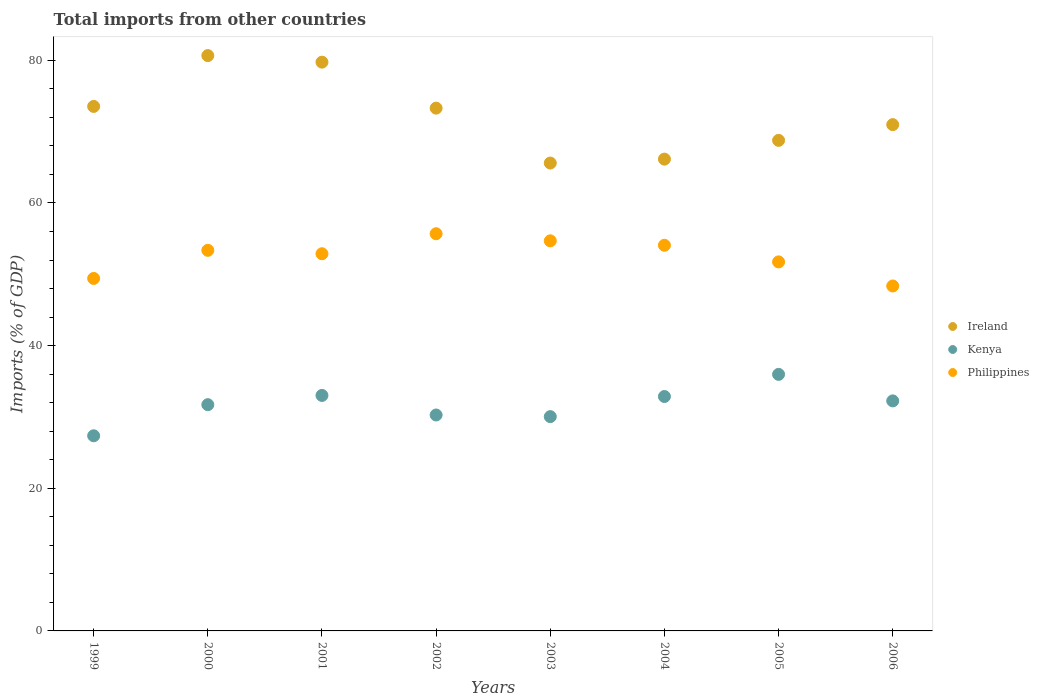How many different coloured dotlines are there?
Your answer should be very brief. 3. What is the total imports in Ireland in 2001?
Your response must be concise. 79.74. Across all years, what is the maximum total imports in Philippines?
Ensure brevity in your answer.  55.69. Across all years, what is the minimum total imports in Kenya?
Make the answer very short. 27.36. In which year was the total imports in Philippines minimum?
Your response must be concise. 2006. What is the total total imports in Kenya in the graph?
Give a very brief answer. 253.5. What is the difference between the total imports in Philippines in 2000 and that in 2001?
Give a very brief answer. 0.48. What is the difference between the total imports in Philippines in 2006 and the total imports in Kenya in 2001?
Offer a terse response. 15.35. What is the average total imports in Philippines per year?
Your response must be concise. 52.53. In the year 2001, what is the difference between the total imports in Ireland and total imports in Philippines?
Give a very brief answer. 26.86. What is the ratio of the total imports in Kenya in 2003 to that in 2004?
Your answer should be very brief. 0.91. What is the difference between the highest and the second highest total imports in Philippines?
Offer a very short reply. 1. What is the difference between the highest and the lowest total imports in Kenya?
Keep it short and to the point. 8.61. In how many years, is the total imports in Kenya greater than the average total imports in Kenya taken over all years?
Offer a terse response. 5. Is the sum of the total imports in Kenya in 2004 and 2005 greater than the maximum total imports in Philippines across all years?
Ensure brevity in your answer.  Yes. Does the total imports in Kenya monotonically increase over the years?
Make the answer very short. No. How many dotlines are there?
Your response must be concise. 3. How many years are there in the graph?
Provide a short and direct response. 8. Are the values on the major ticks of Y-axis written in scientific E-notation?
Your answer should be compact. No. Does the graph contain any zero values?
Your answer should be compact. No. Does the graph contain grids?
Your response must be concise. No. How many legend labels are there?
Keep it short and to the point. 3. What is the title of the graph?
Your answer should be compact. Total imports from other countries. What is the label or title of the Y-axis?
Your answer should be compact. Imports (% of GDP). What is the Imports (% of GDP) of Ireland in 1999?
Your answer should be compact. 73.54. What is the Imports (% of GDP) of Kenya in 1999?
Keep it short and to the point. 27.36. What is the Imports (% of GDP) in Philippines in 1999?
Keep it short and to the point. 49.42. What is the Imports (% of GDP) in Ireland in 2000?
Give a very brief answer. 80.67. What is the Imports (% of GDP) in Kenya in 2000?
Give a very brief answer. 31.72. What is the Imports (% of GDP) in Philippines in 2000?
Ensure brevity in your answer.  53.36. What is the Imports (% of GDP) of Ireland in 2001?
Your answer should be compact. 79.74. What is the Imports (% of GDP) of Kenya in 2001?
Provide a short and direct response. 33.02. What is the Imports (% of GDP) of Philippines in 2001?
Your response must be concise. 52.88. What is the Imports (% of GDP) in Ireland in 2002?
Your answer should be compact. 73.3. What is the Imports (% of GDP) of Kenya in 2002?
Provide a succinct answer. 30.27. What is the Imports (% of GDP) of Philippines in 2002?
Your answer should be very brief. 55.69. What is the Imports (% of GDP) of Ireland in 2003?
Your response must be concise. 65.6. What is the Imports (% of GDP) in Kenya in 2003?
Provide a short and direct response. 30.05. What is the Imports (% of GDP) in Philippines in 2003?
Keep it short and to the point. 54.69. What is the Imports (% of GDP) in Ireland in 2004?
Keep it short and to the point. 66.15. What is the Imports (% of GDP) in Kenya in 2004?
Make the answer very short. 32.87. What is the Imports (% of GDP) in Philippines in 2004?
Offer a terse response. 54.07. What is the Imports (% of GDP) of Ireland in 2005?
Keep it short and to the point. 68.78. What is the Imports (% of GDP) of Kenya in 2005?
Offer a terse response. 35.97. What is the Imports (% of GDP) in Philippines in 2005?
Your answer should be very brief. 51.74. What is the Imports (% of GDP) in Ireland in 2006?
Your answer should be compact. 70.98. What is the Imports (% of GDP) in Kenya in 2006?
Provide a succinct answer. 32.25. What is the Imports (% of GDP) of Philippines in 2006?
Your answer should be very brief. 48.36. Across all years, what is the maximum Imports (% of GDP) in Ireland?
Your response must be concise. 80.67. Across all years, what is the maximum Imports (% of GDP) of Kenya?
Your answer should be compact. 35.97. Across all years, what is the maximum Imports (% of GDP) in Philippines?
Your answer should be very brief. 55.69. Across all years, what is the minimum Imports (% of GDP) of Ireland?
Your answer should be very brief. 65.6. Across all years, what is the minimum Imports (% of GDP) in Kenya?
Offer a terse response. 27.36. Across all years, what is the minimum Imports (% of GDP) of Philippines?
Provide a short and direct response. 48.36. What is the total Imports (% of GDP) of Ireland in the graph?
Ensure brevity in your answer.  578.76. What is the total Imports (% of GDP) in Kenya in the graph?
Offer a terse response. 253.5. What is the total Imports (% of GDP) of Philippines in the graph?
Provide a succinct answer. 420.22. What is the difference between the Imports (% of GDP) in Ireland in 1999 and that in 2000?
Offer a terse response. -7.13. What is the difference between the Imports (% of GDP) in Kenya in 1999 and that in 2000?
Your answer should be very brief. -4.36. What is the difference between the Imports (% of GDP) in Philippines in 1999 and that in 2000?
Provide a short and direct response. -3.94. What is the difference between the Imports (% of GDP) of Ireland in 1999 and that in 2001?
Give a very brief answer. -6.21. What is the difference between the Imports (% of GDP) of Kenya in 1999 and that in 2001?
Offer a terse response. -5.66. What is the difference between the Imports (% of GDP) of Philippines in 1999 and that in 2001?
Offer a terse response. -3.46. What is the difference between the Imports (% of GDP) of Ireland in 1999 and that in 2002?
Keep it short and to the point. 0.24. What is the difference between the Imports (% of GDP) in Kenya in 1999 and that in 2002?
Ensure brevity in your answer.  -2.92. What is the difference between the Imports (% of GDP) in Philippines in 1999 and that in 2002?
Your answer should be very brief. -6.27. What is the difference between the Imports (% of GDP) of Ireland in 1999 and that in 2003?
Your answer should be compact. 7.94. What is the difference between the Imports (% of GDP) in Kenya in 1999 and that in 2003?
Your response must be concise. -2.69. What is the difference between the Imports (% of GDP) in Philippines in 1999 and that in 2003?
Offer a very short reply. -5.27. What is the difference between the Imports (% of GDP) in Ireland in 1999 and that in 2004?
Make the answer very short. 7.39. What is the difference between the Imports (% of GDP) in Kenya in 1999 and that in 2004?
Ensure brevity in your answer.  -5.51. What is the difference between the Imports (% of GDP) of Philippines in 1999 and that in 2004?
Offer a terse response. -4.65. What is the difference between the Imports (% of GDP) of Ireland in 1999 and that in 2005?
Make the answer very short. 4.76. What is the difference between the Imports (% of GDP) of Kenya in 1999 and that in 2005?
Ensure brevity in your answer.  -8.61. What is the difference between the Imports (% of GDP) of Philippines in 1999 and that in 2005?
Offer a very short reply. -2.32. What is the difference between the Imports (% of GDP) of Ireland in 1999 and that in 2006?
Keep it short and to the point. 2.56. What is the difference between the Imports (% of GDP) in Kenya in 1999 and that in 2006?
Keep it short and to the point. -4.89. What is the difference between the Imports (% of GDP) of Philippines in 1999 and that in 2006?
Keep it short and to the point. 1.06. What is the difference between the Imports (% of GDP) in Ireland in 2000 and that in 2001?
Offer a very short reply. 0.92. What is the difference between the Imports (% of GDP) of Kenya in 2000 and that in 2001?
Offer a very short reply. -1.29. What is the difference between the Imports (% of GDP) of Philippines in 2000 and that in 2001?
Make the answer very short. 0.48. What is the difference between the Imports (% of GDP) of Ireland in 2000 and that in 2002?
Give a very brief answer. 7.37. What is the difference between the Imports (% of GDP) in Kenya in 2000 and that in 2002?
Provide a succinct answer. 1.45. What is the difference between the Imports (% of GDP) of Philippines in 2000 and that in 2002?
Make the answer very short. -2.33. What is the difference between the Imports (% of GDP) of Ireland in 2000 and that in 2003?
Keep it short and to the point. 15.07. What is the difference between the Imports (% of GDP) of Kenya in 2000 and that in 2003?
Ensure brevity in your answer.  1.68. What is the difference between the Imports (% of GDP) in Philippines in 2000 and that in 2003?
Your response must be concise. -1.33. What is the difference between the Imports (% of GDP) of Ireland in 2000 and that in 2004?
Make the answer very short. 14.52. What is the difference between the Imports (% of GDP) of Kenya in 2000 and that in 2004?
Your answer should be very brief. -1.15. What is the difference between the Imports (% of GDP) of Philippines in 2000 and that in 2004?
Your answer should be compact. -0.71. What is the difference between the Imports (% of GDP) in Ireland in 2000 and that in 2005?
Offer a very short reply. 11.89. What is the difference between the Imports (% of GDP) of Kenya in 2000 and that in 2005?
Provide a short and direct response. -4.25. What is the difference between the Imports (% of GDP) of Philippines in 2000 and that in 2005?
Your answer should be compact. 1.62. What is the difference between the Imports (% of GDP) of Ireland in 2000 and that in 2006?
Keep it short and to the point. 9.68. What is the difference between the Imports (% of GDP) in Kenya in 2000 and that in 2006?
Give a very brief answer. -0.53. What is the difference between the Imports (% of GDP) in Philippines in 2000 and that in 2006?
Provide a short and direct response. 5. What is the difference between the Imports (% of GDP) in Ireland in 2001 and that in 2002?
Your answer should be very brief. 6.45. What is the difference between the Imports (% of GDP) in Kenya in 2001 and that in 2002?
Ensure brevity in your answer.  2.74. What is the difference between the Imports (% of GDP) in Philippines in 2001 and that in 2002?
Keep it short and to the point. -2.81. What is the difference between the Imports (% of GDP) in Ireland in 2001 and that in 2003?
Offer a terse response. 14.15. What is the difference between the Imports (% of GDP) of Kenya in 2001 and that in 2003?
Offer a very short reply. 2.97. What is the difference between the Imports (% of GDP) in Philippines in 2001 and that in 2003?
Ensure brevity in your answer.  -1.81. What is the difference between the Imports (% of GDP) in Ireland in 2001 and that in 2004?
Provide a succinct answer. 13.6. What is the difference between the Imports (% of GDP) of Kenya in 2001 and that in 2004?
Give a very brief answer. 0.15. What is the difference between the Imports (% of GDP) of Philippines in 2001 and that in 2004?
Your response must be concise. -1.19. What is the difference between the Imports (% of GDP) in Ireland in 2001 and that in 2005?
Make the answer very short. 10.96. What is the difference between the Imports (% of GDP) of Kenya in 2001 and that in 2005?
Provide a succinct answer. -2.95. What is the difference between the Imports (% of GDP) in Philippines in 2001 and that in 2005?
Offer a terse response. 1.14. What is the difference between the Imports (% of GDP) in Ireland in 2001 and that in 2006?
Provide a succinct answer. 8.76. What is the difference between the Imports (% of GDP) of Kenya in 2001 and that in 2006?
Provide a succinct answer. 0.76. What is the difference between the Imports (% of GDP) in Philippines in 2001 and that in 2006?
Give a very brief answer. 4.52. What is the difference between the Imports (% of GDP) of Ireland in 2002 and that in 2003?
Offer a terse response. 7.7. What is the difference between the Imports (% of GDP) in Kenya in 2002 and that in 2003?
Your answer should be very brief. 0.23. What is the difference between the Imports (% of GDP) of Philippines in 2002 and that in 2003?
Offer a very short reply. 1. What is the difference between the Imports (% of GDP) in Ireland in 2002 and that in 2004?
Give a very brief answer. 7.15. What is the difference between the Imports (% of GDP) in Kenya in 2002 and that in 2004?
Offer a very short reply. -2.59. What is the difference between the Imports (% of GDP) in Philippines in 2002 and that in 2004?
Your answer should be compact. 1.62. What is the difference between the Imports (% of GDP) in Ireland in 2002 and that in 2005?
Your answer should be very brief. 4.52. What is the difference between the Imports (% of GDP) of Kenya in 2002 and that in 2005?
Give a very brief answer. -5.7. What is the difference between the Imports (% of GDP) of Philippines in 2002 and that in 2005?
Ensure brevity in your answer.  3.95. What is the difference between the Imports (% of GDP) in Ireland in 2002 and that in 2006?
Give a very brief answer. 2.31. What is the difference between the Imports (% of GDP) of Kenya in 2002 and that in 2006?
Offer a terse response. -1.98. What is the difference between the Imports (% of GDP) of Philippines in 2002 and that in 2006?
Provide a short and direct response. 7.33. What is the difference between the Imports (% of GDP) in Ireland in 2003 and that in 2004?
Make the answer very short. -0.55. What is the difference between the Imports (% of GDP) in Kenya in 2003 and that in 2004?
Provide a short and direct response. -2.82. What is the difference between the Imports (% of GDP) of Philippines in 2003 and that in 2004?
Ensure brevity in your answer.  0.62. What is the difference between the Imports (% of GDP) in Ireland in 2003 and that in 2005?
Ensure brevity in your answer.  -3.18. What is the difference between the Imports (% of GDP) of Kenya in 2003 and that in 2005?
Offer a terse response. -5.92. What is the difference between the Imports (% of GDP) of Philippines in 2003 and that in 2005?
Ensure brevity in your answer.  2.95. What is the difference between the Imports (% of GDP) of Ireland in 2003 and that in 2006?
Provide a succinct answer. -5.38. What is the difference between the Imports (% of GDP) in Kenya in 2003 and that in 2006?
Ensure brevity in your answer.  -2.21. What is the difference between the Imports (% of GDP) in Philippines in 2003 and that in 2006?
Offer a terse response. 6.33. What is the difference between the Imports (% of GDP) of Ireland in 2004 and that in 2005?
Provide a short and direct response. -2.63. What is the difference between the Imports (% of GDP) in Kenya in 2004 and that in 2005?
Your response must be concise. -3.1. What is the difference between the Imports (% of GDP) of Philippines in 2004 and that in 2005?
Provide a short and direct response. 2.33. What is the difference between the Imports (% of GDP) in Ireland in 2004 and that in 2006?
Your answer should be very brief. -4.84. What is the difference between the Imports (% of GDP) in Kenya in 2004 and that in 2006?
Your answer should be compact. 0.62. What is the difference between the Imports (% of GDP) of Philippines in 2004 and that in 2006?
Provide a short and direct response. 5.71. What is the difference between the Imports (% of GDP) in Ireland in 2005 and that in 2006?
Your answer should be compact. -2.2. What is the difference between the Imports (% of GDP) of Kenya in 2005 and that in 2006?
Keep it short and to the point. 3.72. What is the difference between the Imports (% of GDP) in Philippines in 2005 and that in 2006?
Provide a succinct answer. 3.38. What is the difference between the Imports (% of GDP) of Ireland in 1999 and the Imports (% of GDP) of Kenya in 2000?
Offer a terse response. 41.82. What is the difference between the Imports (% of GDP) in Ireland in 1999 and the Imports (% of GDP) in Philippines in 2000?
Provide a succinct answer. 20.18. What is the difference between the Imports (% of GDP) in Kenya in 1999 and the Imports (% of GDP) in Philippines in 2000?
Give a very brief answer. -26. What is the difference between the Imports (% of GDP) in Ireland in 1999 and the Imports (% of GDP) in Kenya in 2001?
Provide a succinct answer. 40.52. What is the difference between the Imports (% of GDP) in Ireland in 1999 and the Imports (% of GDP) in Philippines in 2001?
Give a very brief answer. 20.66. What is the difference between the Imports (% of GDP) of Kenya in 1999 and the Imports (% of GDP) of Philippines in 2001?
Provide a short and direct response. -25.52. What is the difference between the Imports (% of GDP) in Ireland in 1999 and the Imports (% of GDP) in Kenya in 2002?
Your answer should be compact. 43.26. What is the difference between the Imports (% of GDP) in Ireland in 1999 and the Imports (% of GDP) in Philippines in 2002?
Keep it short and to the point. 17.85. What is the difference between the Imports (% of GDP) in Kenya in 1999 and the Imports (% of GDP) in Philippines in 2002?
Your response must be concise. -28.33. What is the difference between the Imports (% of GDP) of Ireland in 1999 and the Imports (% of GDP) of Kenya in 2003?
Your response must be concise. 43.49. What is the difference between the Imports (% of GDP) of Ireland in 1999 and the Imports (% of GDP) of Philippines in 2003?
Keep it short and to the point. 18.85. What is the difference between the Imports (% of GDP) of Kenya in 1999 and the Imports (% of GDP) of Philippines in 2003?
Ensure brevity in your answer.  -27.33. What is the difference between the Imports (% of GDP) in Ireland in 1999 and the Imports (% of GDP) in Kenya in 2004?
Give a very brief answer. 40.67. What is the difference between the Imports (% of GDP) in Ireland in 1999 and the Imports (% of GDP) in Philippines in 2004?
Provide a short and direct response. 19.47. What is the difference between the Imports (% of GDP) of Kenya in 1999 and the Imports (% of GDP) of Philippines in 2004?
Keep it short and to the point. -26.71. What is the difference between the Imports (% of GDP) of Ireland in 1999 and the Imports (% of GDP) of Kenya in 2005?
Give a very brief answer. 37.57. What is the difference between the Imports (% of GDP) of Ireland in 1999 and the Imports (% of GDP) of Philippines in 2005?
Give a very brief answer. 21.8. What is the difference between the Imports (% of GDP) of Kenya in 1999 and the Imports (% of GDP) of Philippines in 2005?
Keep it short and to the point. -24.38. What is the difference between the Imports (% of GDP) in Ireland in 1999 and the Imports (% of GDP) in Kenya in 2006?
Offer a very short reply. 41.29. What is the difference between the Imports (% of GDP) in Ireland in 1999 and the Imports (% of GDP) in Philippines in 2006?
Your answer should be compact. 25.18. What is the difference between the Imports (% of GDP) of Kenya in 1999 and the Imports (% of GDP) of Philippines in 2006?
Keep it short and to the point. -21. What is the difference between the Imports (% of GDP) of Ireland in 2000 and the Imports (% of GDP) of Kenya in 2001?
Your answer should be very brief. 47.65. What is the difference between the Imports (% of GDP) in Ireland in 2000 and the Imports (% of GDP) in Philippines in 2001?
Offer a very short reply. 27.78. What is the difference between the Imports (% of GDP) of Kenya in 2000 and the Imports (% of GDP) of Philippines in 2001?
Your response must be concise. -21.16. What is the difference between the Imports (% of GDP) in Ireland in 2000 and the Imports (% of GDP) in Kenya in 2002?
Ensure brevity in your answer.  50.39. What is the difference between the Imports (% of GDP) in Ireland in 2000 and the Imports (% of GDP) in Philippines in 2002?
Provide a short and direct response. 24.98. What is the difference between the Imports (% of GDP) of Kenya in 2000 and the Imports (% of GDP) of Philippines in 2002?
Keep it short and to the point. -23.97. What is the difference between the Imports (% of GDP) in Ireland in 2000 and the Imports (% of GDP) in Kenya in 2003?
Your response must be concise. 50.62. What is the difference between the Imports (% of GDP) in Ireland in 2000 and the Imports (% of GDP) in Philippines in 2003?
Your answer should be compact. 25.97. What is the difference between the Imports (% of GDP) of Kenya in 2000 and the Imports (% of GDP) of Philippines in 2003?
Provide a succinct answer. -22.97. What is the difference between the Imports (% of GDP) in Ireland in 2000 and the Imports (% of GDP) in Kenya in 2004?
Your answer should be compact. 47.8. What is the difference between the Imports (% of GDP) of Ireland in 2000 and the Imports (% of GDP) of Philippines in 2004?
Ensure brevity in your answer.  26.6. What is the difference between the Imports (% of GDP) in Kenya in 2000 and the Imports (% of GDP) in Philippines in 2004?
Your answer should be very brief. -22.35. What is the difference between the Imports (% of GDP) of Ireland in 2000 and the Imports (% of GDP) of Kenya in 2005?
Offer a very short reply. 44.7. What is the difference between the Imports (% of GDP) in Ireland in 2000 and the Imports (% of GDP) in Philippines in 2005?
Your answer should be compact. 28.92. What is the difference between the Imports (% of GDP) of Kenya in 2000 and the Imports (% of GDP) of Philippines in 2005?
Provide a short and direct response. -20.02. What is the difference between the Imports (% of GDP) of Ireland in 2000 and the Imports (% of GDP) of Kenya in 2006?
Your answer should be compact. 48.41. What is the difference between the Imports (% of GDP) in Ireland in 2000 and the Imports (% of GDP) in Philippines in 2006?
Keep it short and to the point. 32.3. What is the difference between the Imports (% of GDP) in Kenya in 2000 and the Imports (% of GDP) in Philippines in 2006?
Offer a terse response. -16.64. What is the difference between the Imports (% of GDP) of Ireland in 2001 and the Imports (% of GDP) of Kenya in 2002?
Keep it short and to the point. 49.47. What is the difference between the Imports (% of GDP) of Ireland in 2001 and the Imports (% of GDP) of Philippines in 2002?
Your answer should be very brief. 24.06. What is the difference between the Imports (% of GDP) in Kenya in 2001 and the Imports (% of GDP) in Philippines in 2002?
Provide a short and direct response. -22.67. What is the difference between the Imports (% of GDP) of Ireland in 2001 and the Imports (% of GDP) of Kenya in 2003?
Ensure brevity in your answer.  49.7. What is the difference between the Imports (% of GDP) in Ireland in 2001 and the Imports (% of GDP) in Philippines in 2003?
Offer a very short reply. 25.05. What is the difference between the Imports (% of GDP) of Kenya in 2001 and the Imports (% of GDP) of Philippines in 2003?
Your response must be concise. -21.68. What is the difference between the Imports (% of GDP) of Ireland in 2001 and the Imports (% of GDP) of Kenya in 2004?
Provide a short and direct response. 46.88. What is the difference between the Imports (% of GDP) of Ireland in 2001 and the Imports (% of GDP) of Philippines in 2004?
Offer a terse response. 25.67. What is the difference between the Imports (% of GDP) in Kenya in 2001 and the Imports (% of GDP) in Philippines in 2004?
Offer a terse response. -21.05. What is the difference between the Imports (% of GDP) of Ireland in 2001 and the Imports (% of GDP) of Kenya in 2005?
Your response must be concise. 43.77. What is the difference between the Imports (% of GDP) in Ireland in 2001 and the Imports (% of GDP) in Philippines in 2005?
Offer a terse response. 28. What is the difference between the Imports (% of GDP) of Kenya in 2001 and the Imports (% of GDP) of Philippines in 2005?
Offer a terse response. -18.73. What is the difference between the Imports (% of GDP) in Ireland in 2001 and the Imports (% of GDP) in Kenya in 2006?
Give a very brief answer. 47.49. What is the difference between the Imports (% of GDP) of Ireland in 2001 and the Imports (% of GDP) of Philippines in 2006?
Ensure brevity in your answer.  31.38. What is the difference between the Imports (% of GDP) of Kenya in 2001 and the Imports (% of GDP) of Philippines in 2006?
Your response must be concise. -15.35. What is the difference between the Imports (% of GDP) of Ireland in 2002 and the Imports (% of GDP) of Kenya in 2003?
Keep it short and to the point. 43.25. What is the difference between the Imports (% of GDP) of Ireland in 2002 and the Imports (% of GDP) of Philippines in 2003?
Your answer should be very brief. 18.61. What is the difference between the Imports (% of GDP) in Kenya in 2002 and the Imports (% of GDP) in Philippines in 2003?
Offer a very short reply. -24.42. What is the difference between the Imports (% of GDP) of Ireland in 2002 and the Imports (% of GDP) of Kenya in 2004?
Give a very brief answer. 40.43. What is the difference between the Imports (% of GDP) of Ireland in 2002 and the Imports (% of GDP) of Philippines in 2004?
Keep it short and to the point. 19.23. What is the difference between the Imports (% of GDP) in Kenya in 2002 and the Imports (% of GDP) in Philippines in 2004?
Keep it short and to the point. -23.8. What is the difference between the Imports (% of GDP) of Ireland in 2002 and the Imports (% of GDP) of Kenya in 2005?
Ensure brevity in your answer.  37.33. What is the difference between the Imports (% of GDP) in Ireland in 2002 and the Imports (% of GDP) in Philippines in 2005?
Offer a terse response. 21.56. What is the difference between the Imports (% of GDP) of Kenya in 2002 and the Imports (% of GDP) of Philippines in 2005?
Your answer should be compact. -21.47. What is the difference between the Imports (% of GDP) of Ireland in 2002 and the Imports (% of GDP) of Kenya in 2006?
Your answer should be very brief. 41.05. What is the difference between the Imports (% of GDP) of Ireland in 2002 and the Imports (% of GDP) of Philippines in 2006?
Offer a terse response. 24.93. What is the difference between the Imports (% of GDP) in Kenya in 2002 and the Imports (% of GDP) in Philippines in 2006?
Your answer should be very brief. -18.09. What is the difference between the Imports (% of GDP) in Ireland in 2003 and the Imports (% of GDP) in Kenya in 2004?
Provide a short and direct response. 32.73. What is the difference between the Imports (% of GDP) in Ireland in 2003 and the Imports (% of GDP) in Philippines in 2004?
Your response must be concise. 11.53. What is the difference between the Imports (% of GDP) in Kenya in 2003 and the Imports (% of GDP) in Philippines in 2004?
Ensure brevity in your answer.  -24.02. What is the difference between the Imports (% of GDP) of Ireland in 2003 and the Imports (% of GDP) of Kenya in 2005?
Ensure brevity in your answer.  29.63. What is the difference between the Imports (% of GDP) of Ireland in 2003 and the Imports (% of GDP) of Philippines in 2005?
Keep it short and to the point. 13.86. What is the difference between the Imports (% of GDP) of Kenya in 2003 and the Imports (% of GDP) of Philippines in 2005?
Provide a short and direct response. -21.7. What is the difference between the Imports (% of GDP) of Ireland in 2003 and the Imports (% of GDP) of Kenya in 2006?
Your answer should be compact. 33.35. What is the difference between the Imports (% of GDP) in Ireland in 2003 and the Imports (% of GDP) in Philippines in 2006?
Provide a short and direct response. 17.24. What is the difference between the Imports (% of GDP) in Kenya in 2003 and the Imports (% of GDP) in Philippines in 2006?
Give a very brief answer. -18.32. What is the difference between the Imports (% of GDP) in Ireland in 2004 and the Imports (% of GDP) in Kenya in 2005?
Provide a short and direct response. 30.18. What is the difference between the Imports (% of GDP) of Ireland in 2004 and the Imports (% of GDP) of Philippines in 2005?
Ensure brevity in your answer.  14.41. What is the difference between the Imports (% of GDP) in Kenya in 2004 and the Imports (% of GDP) in Philippines in 2005?
Provide a succinct answer. -18.87. What is the difference between the Imports (% of GDP) of Ireland in 2004 and the Imports (% of GDP) of Kenya in 2006?
Your answer should be compact. 33.9. What is the difference between the Imports (% of GDP) in Ireland in 2004 and the Imports (% of GDP) in Philippines in 2006?
Give a very brief answer. 17.78. What is the difference between the Imports (% of GDP) of Kenya in 2004 and the Imports (% of GDP) of Philippines in 2006?
Ensure brevity in your answer.  -15.5. What is the difference between the Imports (% of GDP) of Ireland in 2005 and the Imports (% of GDP) of Kenya in 2006?
Provide a short and direct response. 36.53. What is the difference between the Imports (% of GDP) in Ireland in 2005 and the Imports (% of GDP) in Philippines in 2006?
Offer a very short reply. 20.42. What is the difference between the Imports (% of GDP) in Kenya in 2005 and the Imports (% of GDP) in Philippines in 2006?
Offer a terse response. -12.39. What is the average Imports (% of GDP) of Ireland per year?
Offer a terse response. 72.34. What is the average Imports (% of GDP) of Kenya per year?
Your response must be concise. 31.69. What is the average Imports (% of GDP) in Philippines per year?
Your response must be concise. 52.53. In the year 1999, what is the difference between the Imports (% of GDP) of Ireland and Imports (% of GDP) of Kenya?
Provide a succinct answer. 46.18. In the year 1999, what is the difference between the Imports (% of GDP) of Ireland and Imports (% of GDP) of Philippines?
Keep it short and to the point. 24.12. In the year 1999, what is the difference between the Imports (% of GDP) in Kenya and Imports (% of GDP) in Philippines?
Your answer should be very brief. -22.06. In the year 2000, what is the difference between the Imports (% of GDP) of Ireland and Imports (% of GDP) of Kenya?
Your answer should be very brief. 48.94. In the year 2000, what is the difference between the Imports (% of GDP) of Ireland and Imports (% of GDP) of Philippines?
Provide a short and direct response. 27.31. In the year 2000, what is the difference between the Imports (% of GDP) in Kenya and Imports (% of GDP) in Philippines?
Ensure brevity in your answer.  -21.64. In the year 2001, what is the difference between the Imports (% of GDP) in Ireland and Imports (% of GDP) in Kenya?
Provide a succinct answer. 46.73. In the year 2001, what is the difference between the Imports (% of GDP) of Ireland and Imports (% of GDP) of Philippines?
Make the answer very short. 26.86. In the year 2001, what is the difference between the Imports (% of GDP) of Kenya and Imports (% of GDP) of Philippines?
Your answer should be very brief. -19.87. In the year 2002, what is the difference between the Imports (% of GDP) in Ireland and Imports (% of GDP) in Kenya?
Provide a short and direct response. 43.02. In the year 2002, what is the difference between the Imports (% of GDP) of Ireland and Imports (% of GDP) of Philippines?
Your answer should be very brief. 17.61. In the year 2002, what is the difference between the Imports (% of GDP) of Kenya and Imports (% of GDP) of Philippines?
Your response must be concise. -25.41. In the year 2003, what is the difference between the Imports (% of GDP) of Ireland and Imports (% of GDP) of Kenya?
Ensure brevity in your answer.  35.55. In the year 2003, what is the difference between the Imports (% of GDP) in Ireland and Imports (% of GDP) in Philippines?
Offer a very short reply. 10.91. In the year 2003, what is the difference between the Imports (% of GDP) in Kenya and Imports (% of GDP) in Philippines?
Your response must be concise. -24.65. In the year 2004, what is the difference between the Imports (% of GDP) in Ireland and Imports (% of GDP) in Kenya?
Provide a short and direct response. 33.28. In the year 2004, what is the difference between the Imports (% of GDP) of Ireland and Imports (% of GDP) of Philippines?
Your response must be concise. 12.08. In the year 2004, what is the difference between the Imports (% of GDP) of Kenya and Imports (% of GDP) of Philippines?
Provide a succinct answer. -21.2. In the year 2005, what is the difference between the Imports (% of GDP) of Ireland and Imports (% of GDP) of Kenya?
Provide a succinct answer. 32.81. In the year 2005, what is the difference between the Imports (% of GDP) of Ireland and Imports (% of GDP) of Philippines?
Give a very brief answer. 17.04. In the year 2005, what is the difference between the Imports (% of GDP) of Kenya and Imports (% of GDP) of Philippines?
Offer a very short reply. -15.77. In the year 2006, what is the difference between the Imports (% of GDP) in Ireland and Imports (% of GDP) in Kenya?
Your response must be concise. 38.73. In the year 2006, what is the difference between the Imports (% of GDP) of Ireland and Imports (% of GDP) of Philippines?
Your answer should be compact. 22.62. In the year 2006, what is the difference between the Imports (% of GDP) in Kenya and Imports (% of GDP) in Philippines?
Provide a short and direct response. -16.11. What is the ratio of the Imports (% of GDP) in Ireland in 1999 to that in 2000?
Your answer should be compact. 0.91. What is the ratio of the Imports (% of GDP) in Kenya in 1999 to that in 2000?
Offer a terse response. 0.86. What is the ratio of the Imports (% of GDP) in Philippines in 1999 to that in 2000?
Offer a very short reply. 0.93. What is the ratio of the Imports (% of GDP) in Ireland in 1999 to that in 2001?
Ensure brevity in your answer.  0.92. What is the ratio of the Imports (% of GDP) in Kenya in 1999 to that in 2001?
Offer a very short reply. 0.83. What is the ratio of the Imports (% of GDP) in Philippines in 1999 to that in 2001?
Keep it short and to the point. 0.93. What is the ratio of the Imports (% of GDP) of Kenya in 1999 to that in 2002?
Keep it short and to the point. 0.9. What is the ratio of the Imports (% of GDP) in Philippines in 1999 to that in 2002?
Your answer should be very brief. 0.89. What is the ratio of the Imports (% of GDP) of Ireland in 1999 to that in 2003?
Ensure brevity in your answer.  1.12. What is the ratio of the Imports (% of GDP) in Kenya in 1999 to that in 2003?
Your answer should be compact. 0.91. What is the ratio of the Imports (% of GDP) of Philippines in 1999 to that in 2003?
Make the answer very short. 0.9. What is the ratio of the Imports (% of GDP) in Ireland in 1999 to that in 2004?
Offer a terse response. 1.11. What is the ratio of the Imports (% of GDP) in Kenya in 1999 to that in 2004?
Provide a short and direct response. 0.83. What is the ratio of the Imports (% of GDP) in Philippines in 1999 to that in 2004?
Your response must be concise. 0.91. What is the ratio of the Imports (% of GDP) of Ireland in 1999 to that in 2005?
Provide a succinct answer. 1.07. What is the ratio of the Imports (% of GDP) of Kenya in 1999 to that in 2005?
Your answer should be compact. 0.76. What is the ratio of the Imports (% of GDP) in Philippines in 1999 to that in 2005?
Provide a succinct answer. 0.96. What is the ratio of the Imports (% of GDP) of Ireland in 1999 to that in 2006?
Provide a succinct answer. 1.04. What is the ratio of the Imports (% of GDP) in Kenya in 1999 to that in 2006?
Ensure brevity in your answer.  0.85. What is the ratio of the Imports (% of GDP) in Philippines in 1999 to that in 2006?
Ensure brevity in your answer.  1.02. What is the ratio of the Imports (% of GDP) in Ireland in 2000 to that in 2001?
Give a very brief answer. 1.01. What is the ratio of the Imports (% of GDP) in Kenya in 2000 to that in 2001?
Ensure brevity in your answer.  0.96. What is the ratio of the Imports (% of GDP) in Ireland in 2000 to that in 2002?
Give a very brief answer. 1.1. What is the ratio of the Imports (% of GDP) in Kenya in 2000 to that in 2002?
Give a very brief answer. 1.05. What is the ratio of the Imports (% of GDP) in Philippines in 2000 to that in 2002?
Your answer should be compact. 0.96. What is the ratio of the Imports (% of GDP) of Ireland in 2000 to that in 2003?
Provide a short and direct response. 1.23. What is the ratio of the Imports (% of GDP) of Kenya in 2000 to that in 2003?
Offer a terse response. 1.06. What is the ratio of the Imports (% of GDP) of Philippines in 2000 to that in 2003?
Offer a terse response. 0.98. What is the ratio of the Imports (% of GDP) in Ireland in 2000 to that in 2004?
Your response must be concise. 1.22. What is the ratio of the Imports (% of GDP) in Kenya in 2000 to that in 2004?
Offer a terse response. 0.97. What is the ratio of the Imports (% of GDP) of Philippines in 2000 to that in 2004?
Provide a succinct answer. 0.99. What is the ratio of the Imports (% of GDP) in Ireland in 2000 to that in 2005?
Make the answer very short. 1.17. What is the ratio of the Imports (% of GDP) in Kenya in 2000 to that in 2005?
Your response must be concise. 0.88. What is the ratio of the Imports (% of GDP) of Philippines in 2000 to that in 2005?
Make the answer very short. 1.03. What is the ratio of the Imports (% of GDP) in Ireland in 2000 to that in 2006?
Your answer should be very brief. 1.14. What is the ratio of the Imports (% of GDP) of Kenya in 2000 to that in 2006?
Offer a very short reply. 0.98. What is the ratio of the Imports (% of GDP) in Philippines in 2000 to that in 2006?
Give a very brief answer. 1.1. What is the ratio of the Imports (% of GDP) of Ireland in 2001 to that in 2002?
Offer a terse response. 1.09. What is the ratio of the Imports (% of GDP) in Kenya in 2001 to that in 2002?
Provide a short and direct response. 1.09. What is the ratio of the Imports (% of GDP) in Philippines in 2001 to that in 2002?
Offer a terse response. 0.95. What is the ratio of the Imports (% of GDP) of Ireland in 2001 to that in 2003?
Provide a short and direct response. 1.22. What is the ratio of the Imports (% of GDP) in Kenya in 2001 to that in 2003?
Keep it short and to the point. 1.1. What is the ratio of the Imports (% of GDP) in Philippines in 2001 to that in 2003?
Provide a short and direct response. 0.97. What is the ratio of the Imports (% of GDP) in Ireland in 2001 to that in 2004?
Keep it short and to the point. 1.21. What is the ratio of the Imports (% of GDP) of Kenya in 2001 to that in 2004?
Your answer should be compact. 1. What is the ratio of the Imports (% of GDP) in Philippines in 2001 to that in 2004?
Your response must be concise. 0.98. What is the ratio of the Imports (% of GDP) in Ireland in 2001 to that in 2005?
Your answer should be compact. 1.16. What is the ratio of the Imports (% of GDP) in Kenya in 2001 to that in 2005?
Provide a succinct answer. 0.92. What is the ratio of the Imports (% of GDP) of Ireland in 2001 to that in 2006?
Your answer should be compact. 1.12. What is the ratio of the Imports (% of GDP) of Kenya in 2001 to that in 2006?
Make the answer very short. 1.02. What is the ratio of the Imports (% of GDP) of Philippines in 2001 to that in 2006?
Offer a terse response. 1.09. What is the ratio of the Imports (% of GDP) in Ireland in 2002 to that in 2003?
Keep it short and to the point. 1.12. What is the ratio of the Imports (% of GDP) of Kenya in 2002 to that in 2003?
Your response must be concise. 1.01. What is the ratio of the Imports (% of GDP) in Philippines in 2002 to that in 2003?
Provide a succinct answer. 1.02. What is the ratio of the Imports (% of GDP) in Ireland in 2002 to that in 2004?
Provide a short and direct response. 1.11. What is the ratio of the Imports (% of GDP) of Kenya in 2002 to that in 2004?
Ensure brevity in your answer.  0.92. What is the ratio of the Imports (% of GDP) in Philippines in 2002 to that in 2004?
Offer a very short reply. 1.03. What is the ratio of the Imports (% of GDP) in Ireland in 2002 to that in 2005?
Provide a succinct answer. 1.07. What is the ratio of the Imports (% of GDP) of Kenya in 2002 to that in 2005?
Keep it short and to the point. 0.84. What is the ratio of the Imports (% of GDP) of Philippines in 2002 to that in 2005?
Make the answer very short. 1.08. What is the ratio of the Imports (% of GDP) in Ireland in 2002 to that in 2006?
Offer a very short reply. 1.03. What is the ratio of the Imports (% of GDP) of Kenya in 2002 to that in 2006?
Offer a terse response. 0.94. What is the ratio of the Imports (% of GDP) in Philippines in 2002 to that in 2006?
Offer a terse response. 1.15. What is the ratio of the Imports (% of GDP) in Kenya in 2003 to that in 2004?
Your answer should be compact. 0.91. What is the ratio of the Imports (% of GDP) of Philippines in 2003 to that in 2004?
Offer a very short reply. 1.01. What is the ratio of the Imports (% of GDP) of Ireland in 2003 to that in 2005?
Your answer should be compact. 0.95. What is the ratio of the Imports (% of GDP) in Kenya in 2003 to that in 2005?
Provide a succinct answer. 0.84. What is the ratio of the Imports (% of GDP) in Philippines in 2003 to that in 2005?
Provide a succinct answer. 1.06. What is the ratio of the Imports (% of GDP) in Ireland in 2003 to that in 2006?
Your answer should be compact. 0.92. What is the ratio of the Imports (% of GDP) of Kenya in 2003 to that in 2006?
Offer a terse response. 0.93. What is the ratio of the Imports (% of GDP) of Philippines in 2003 to that in 2006?
Make the answer very short. 1.13. What is the ratio of the Imports (% of GDP) in Ireland in 2004 to that in 2005?
Offer a very short reply. 0.96. What is the ratio of the Imports (% of GDP) of Kenya in 2004 to that in 2005?
Keep it short and to the point. 0.91. What is the ratio of the Imports (% of GDP) of Philippines in 2004 to that in 2005?
Give a very brief answer. 1.04. What is the ratio of the Imports (% of GDP) of Ireland in 2004 to that in 2006?
Ensure brevity in your answer.  0.93. What is the ratio of the Imports (% of GDP) in Kenya in 2004 to that in 2006?
Offer a terse response. 1.02. What is the ratio of the Imports (% of GDP) in Philippines in 2004 to that in 2006?
Give a very brief answer. 1.12. What is the ratio of the Imports (% of GDP) of Kenya in 2005 to that in 2006?
Provide a succinct answer. 1.12. What is the ratio of the Imports (% of GDP) in Philippines in 2005 to that in 2006?
Your answer should be compact. 1.07. What is the difference between the highest and the second highest Imports (% of GDP) in Ireland?
Your response must be concise. 0.92. What is the difference between the highest and the second highest Imports (% of GDP) of Kenya?
Ensure brevity in your answer.  2.95. What is the difference between the highest and the second highest Imports (% of GDP) of Philippines?
Offer a terse response. 1. What is the difference between the highest and the lowest Imports (% of GDP) of Ireland?
Provide a short and direct response. 15.07. What is the difference between the highest and the lowest Imports (% of GDP) in Kenya?
Provide a short and direct response. 8.61. What is the difference between the highest and the lowest Imports (% of GDP) in Philippines?
Keep it short and to the point. 7.33. 